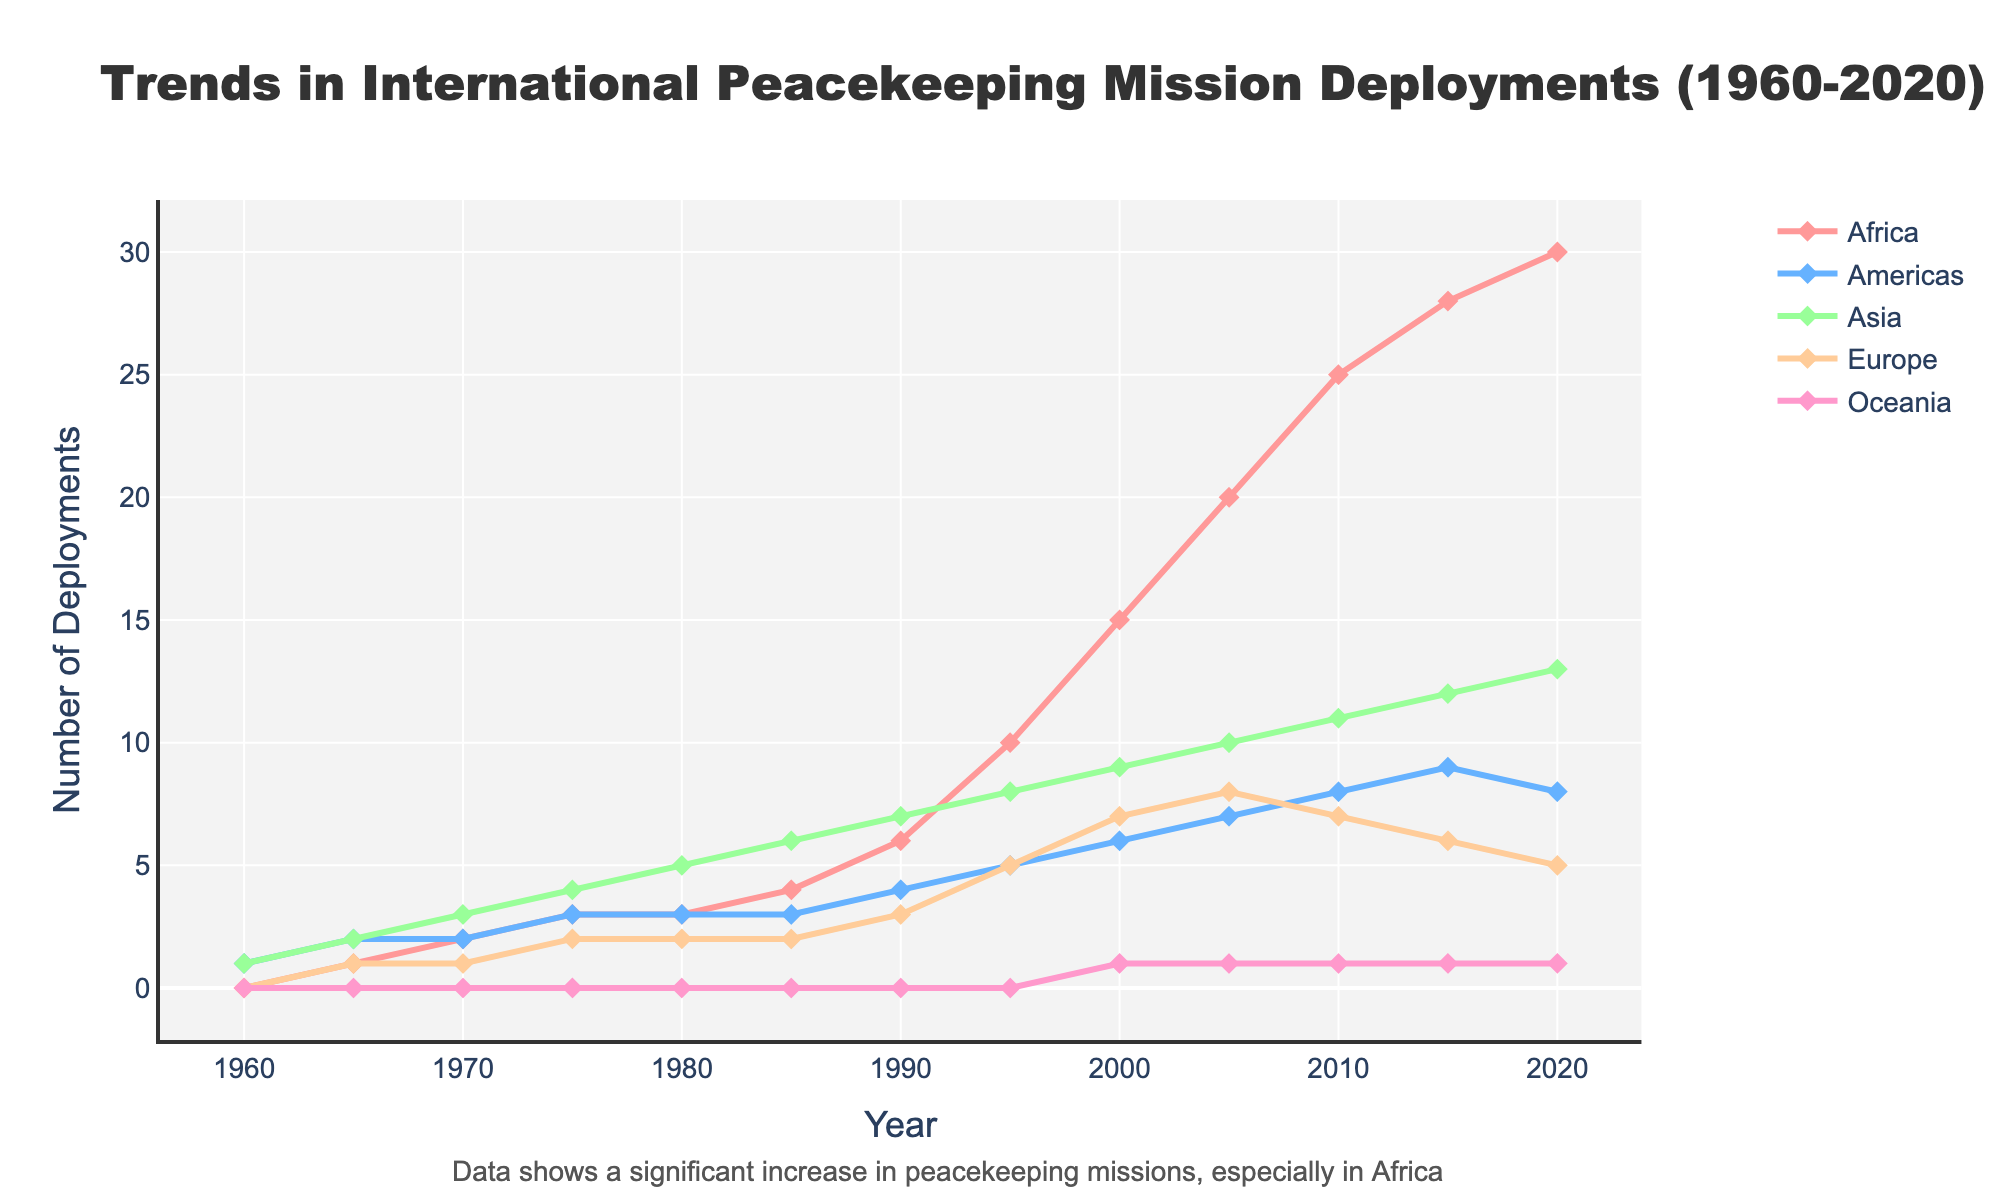What is the total number of deployments in Asia and Europe in the year 2000? To find this, look at the data points for Asia and Europe in the year 2000 (which are 9 and 7 respectively) and sum them up (9 + 7).
Answer: 16 Between 1960 and 2020, in which year did Africa experience the highest increase in peacekeeping mission deployments compared to the previous recorded year? Identify the year-to-year differences in Africa's deployments and pinpoint the maximum change. The largest increase was from 10 in 1995 to 15 in 2000, thus 1995 to 2000.
Answer: 1995-2000 How many more deployments did Africa have compared to the Americas in 2010? Find the number of deployments for Africa (25) and the Americas (8) in 2010, then subtract the latter from the former (25 - 8).
Answer: 17 Which region saw the least growth in deployments from 1960 to 2020? Compare the change in numbers between 1960 and 2020 for all regions: Africa (30-0), Americas (8-1), Asia (13-1), Europe (5-0), and Oceania (1-0). The Americas saw the smallest increase of 7 relative to the initial value.
Answer: Americas How does the trend in the number of peacekeeping missions in Asia compare to Europe from 1990 to 2020? Examine the trend lines from 1990 to 2020: Asia’s deployments increased from 7 to 13, while Europe’s deployments initially rose from 3 to 8 until 2005, then decreased to 5 by 2020. Thus, Asia consistently increased while Europe fluctuated.
Answer: Asia increased, Europe fluctuated Which region had the largest number of deployments in 2020 and what is the number? Look at the end points of the lines for each region in 2020. Africa has the highest number with 30 deployments.
Answer: Africa, 30 What is the average number of deployments in the Americas from 1985 to 2015? Identify the values for the Americas in 1985 (3), 1990 (4), 1995 (5), 2000 (6), 2005 (7), 2010 (8), and 2015 (9). Sum these values (3+4+5+6+7+8+9=42) and divide by the number of data points (7).
Answer: 6 Which year saw the first peacekeeping mission deployment in Africa? Look at the data points for Africa and identify the first year it changes from 0. The first year is 1965.
Answer: 1965 